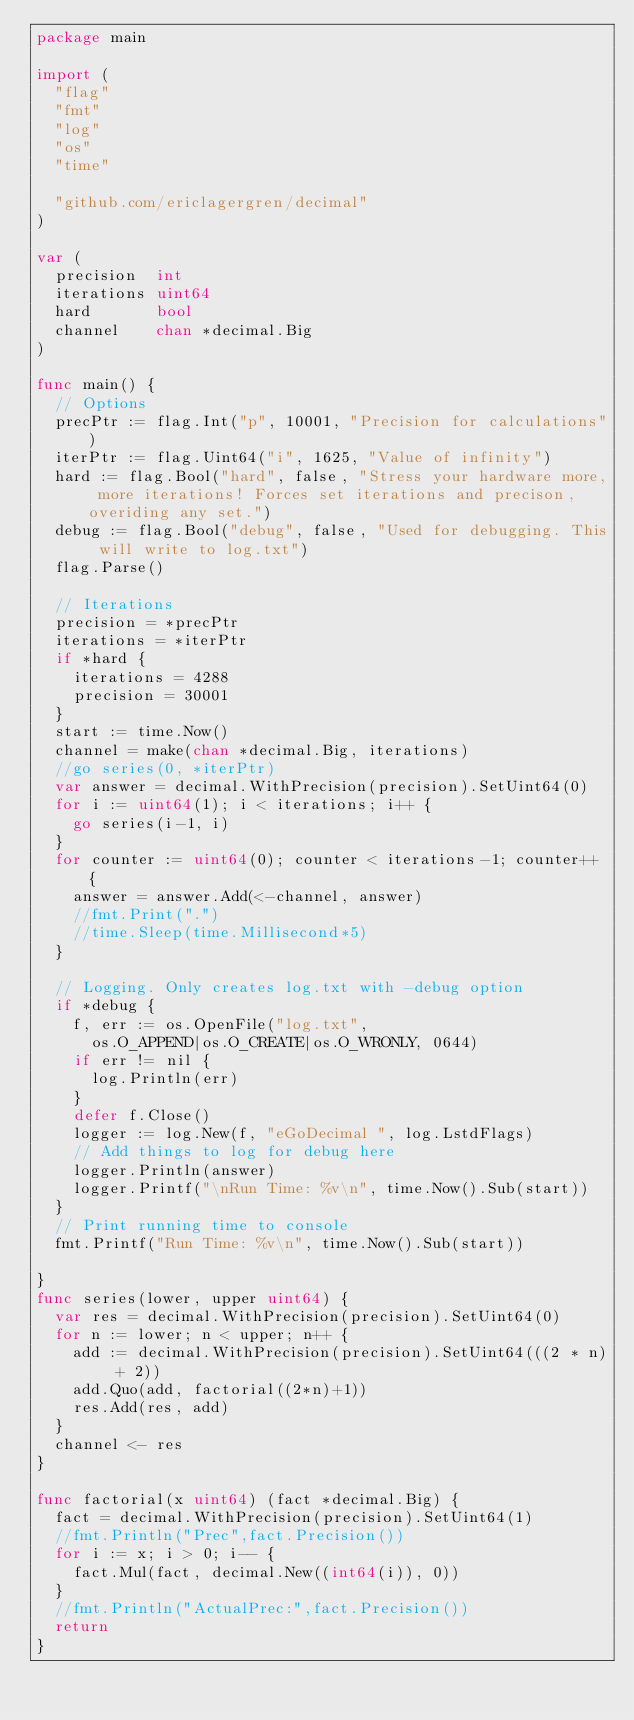Convert code to text. <code><loc_0><loc_0><loc_500><loc_500><_Go_>package main

import (
	"flag"
	"fmt"
	"log"
	"os"
	"time"

	"github.com/ericlagergren/decimal"
)

var (
	precision  int
	iterations uint64
	hard       bool
	channel    chan *decimal.Big
)

func main() {
	// Options
	precPtr := flag.Int("p", 10001, "Precision for calculations")
	iterPtr := flag.Uint64("i", 1625, "Value of infinity")
	hard := flag.Bool("hard", false, "Stress your hardware more, more iterations! Forces set iterations and precison, overiding any set.")
	debug := flag.Bool("debug", false, "Used for debugging. This will write to log.txt")
	flag.Parse()

	// Iterations
	precision = *precPtr
	iterations = *iterPtr
	if *hard {
		iterations = 4288
		precision = 30001
	}
	start := time.Now()
	channel = make(chan *decimal.Big, iterations)
	//go series(0, *iterPtr)
	var answer = decimal.WithPrecision(precision).SetUint64(0)
	for i := uint64(1); i < iterations; i++ {
		go series(i-1, i)
	}
	for counter := uint64(0); counter < iterations-1; counter++ {
		answer = answer.Add(<-channel, answer)
		//fmt.Print(".")
		//time.Sleep(time.Millisecond*5)
	}

	// Logging. Only creates log.txt with -debug option
	if *debug {
		f, err := os.OpenFile("log.txt",
			os.O_APPEND|os.O_CREATE|os.O_WRONLY, 0644)
		if err != nil {
			log.Println(err)
		}
		defer f.Close()
		logger := log.New(f, "eGoDecimal ", log.LstdFlags)
		// Add things to log for debug here
		logger.Println(answer)
		logger.Printf("\nRun Time: %v\n", time.Now().Sub(start))
	}
	// Print running time to console
	fmt.Printf("Run Time: %v\n", time.Now().Sub(start))

}
func series(lower, upper uint64) {
	var res = decimal.WithPrecision(precision).SetUint64(0)
	for n := lower; n < upper; n++ {
		add := decimal.WithPrecision(precision).SetUint64(((2 * n) + 2))
		add.Quo(add, factorial((2*n)+1))
		res.Add(res, add)
	}
	channel <- res
}

func factorial(x uint64) (fact *decimal.Big) {
	fact = decimal.WithPrecision(precision).SetUint64(1)
	//fmt.Println("Prec",fact.Precision())
	for i := x; i > 0; i-- {
		fact.Mul(fact, decimal.New((int64(i)), 0))
	}
	//fmt.Println("ActualPrec:",fact.Precision())
	return
}
</code> 